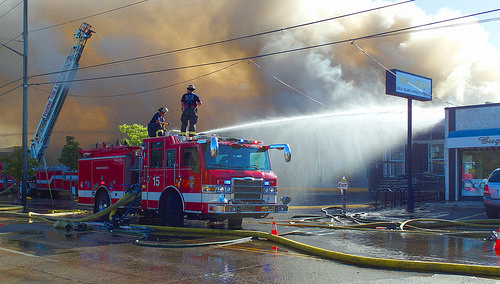<image>
Is the man on the fire engine? Yes. Looking at the image, I can see the man is positioned on top of the fire engine, with the fire engine providing support. Where is the man in relation to the truck? Is it above the truck? Yes. The man is positioned above the truck in the vertical space, higher up in the scene. Is there a fire truck above the hose? No. The fire truck is not positioned above the hose. The vertical arrangement shows a different relationship. 